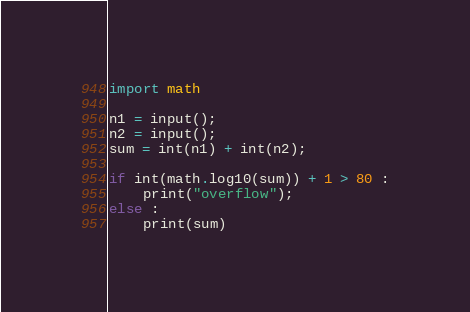Convert code to text. <code><loc_0><loc_0><loc_500><loc_500><_Python_>import math

n1 = input();
n2 = input();
sum = int(n1) + int(n2);

if int(math.log10(sum)) + 1 > 80 :
	print("overflow");
else :
	print(sum) </code> 